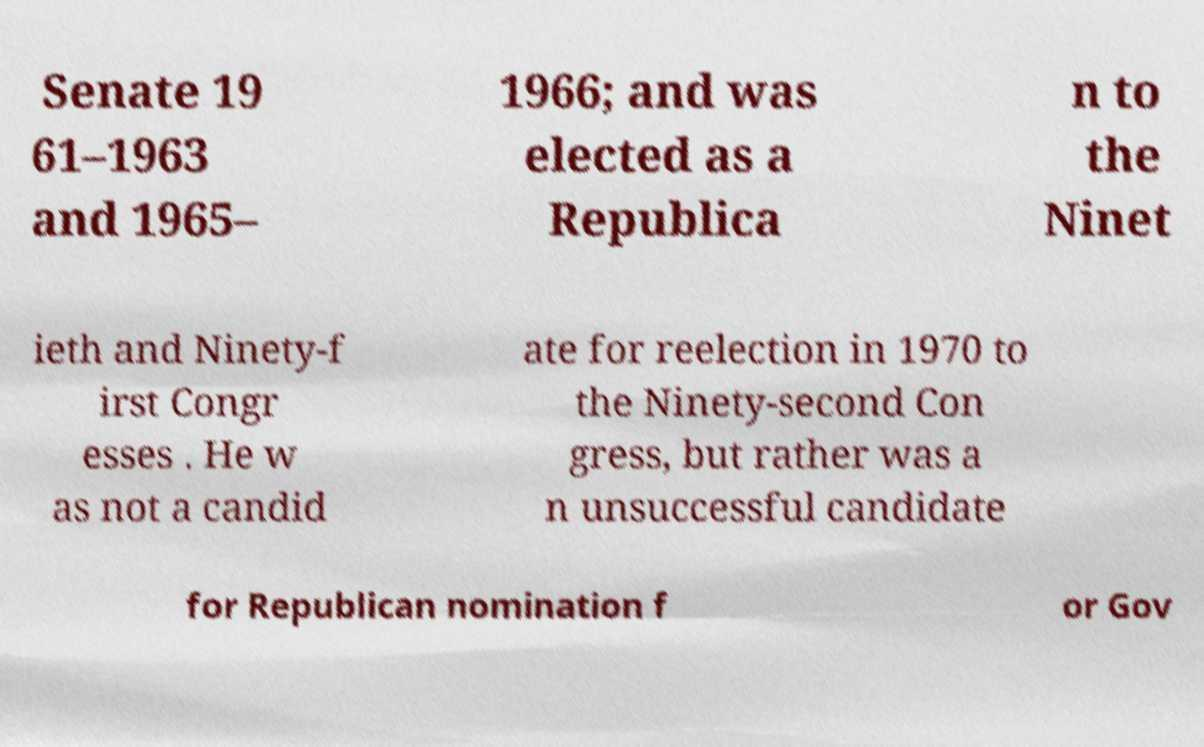I need the written content from this picture converted into text. Can you do that? Senate 19 61–1963 and 1965– 1966; and was elected as a Republica n to the Ninet ieth and Ninety-f irst Congr esses . He w as not a candid ate for reelection in 1970 to the Ninety-second Con gress, but rather was a n unsuccessful candidate for Republican nomination f or Gov 